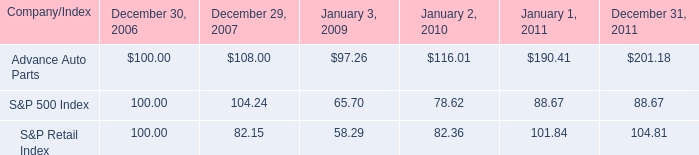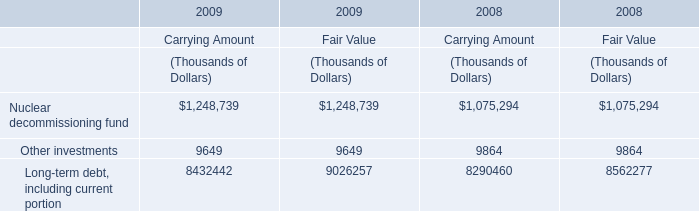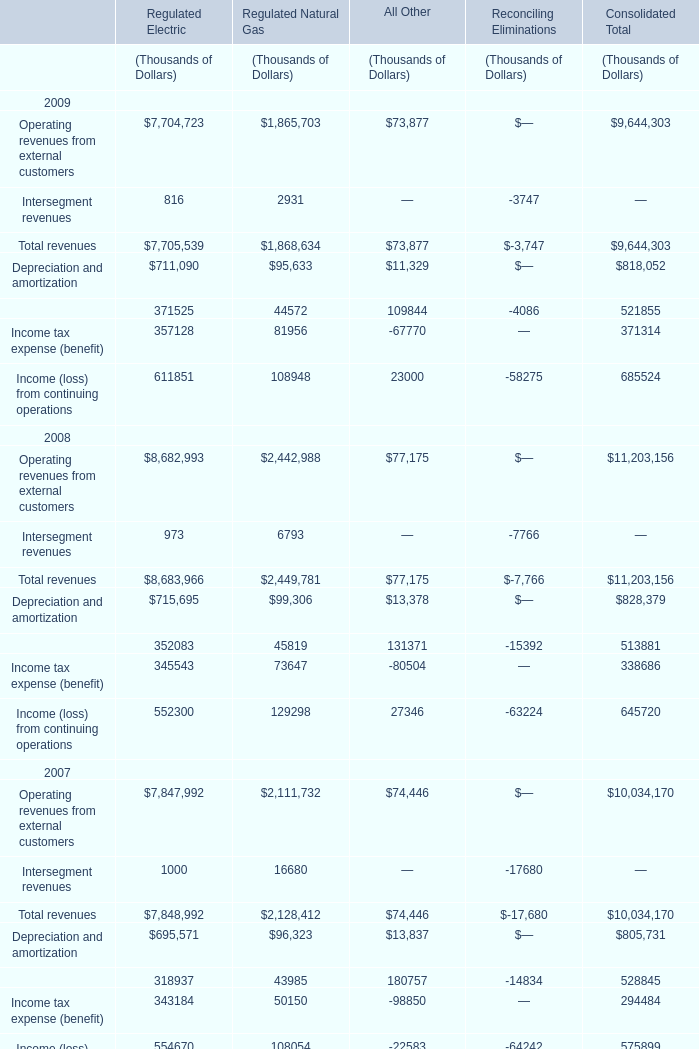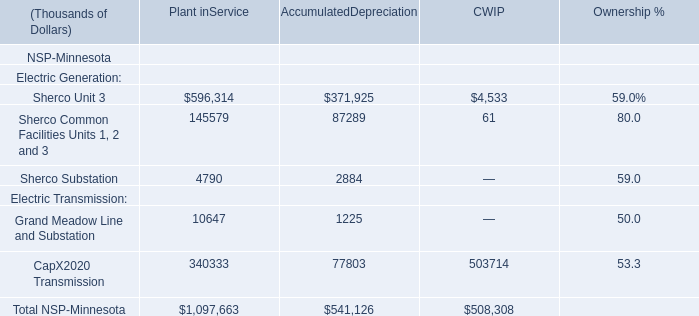In which year is the value of the Total revenues for Regulated Natural Gas greater than 2400000 thousand? 
Answer: 2008. 